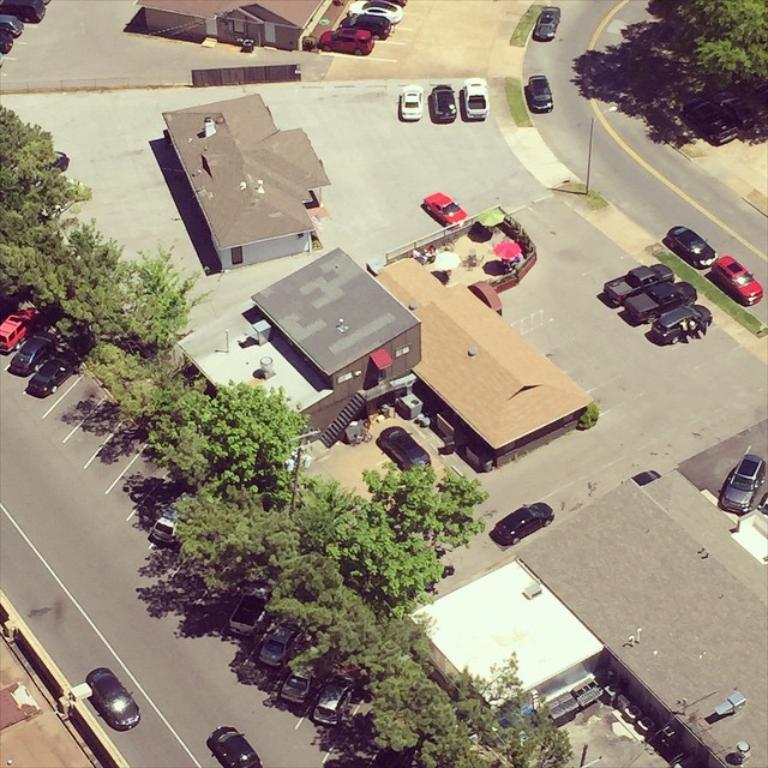Please provide a concise description of this image. In this picture there are buildings and trees and poles and there are vehicles on the road and there are wires. 